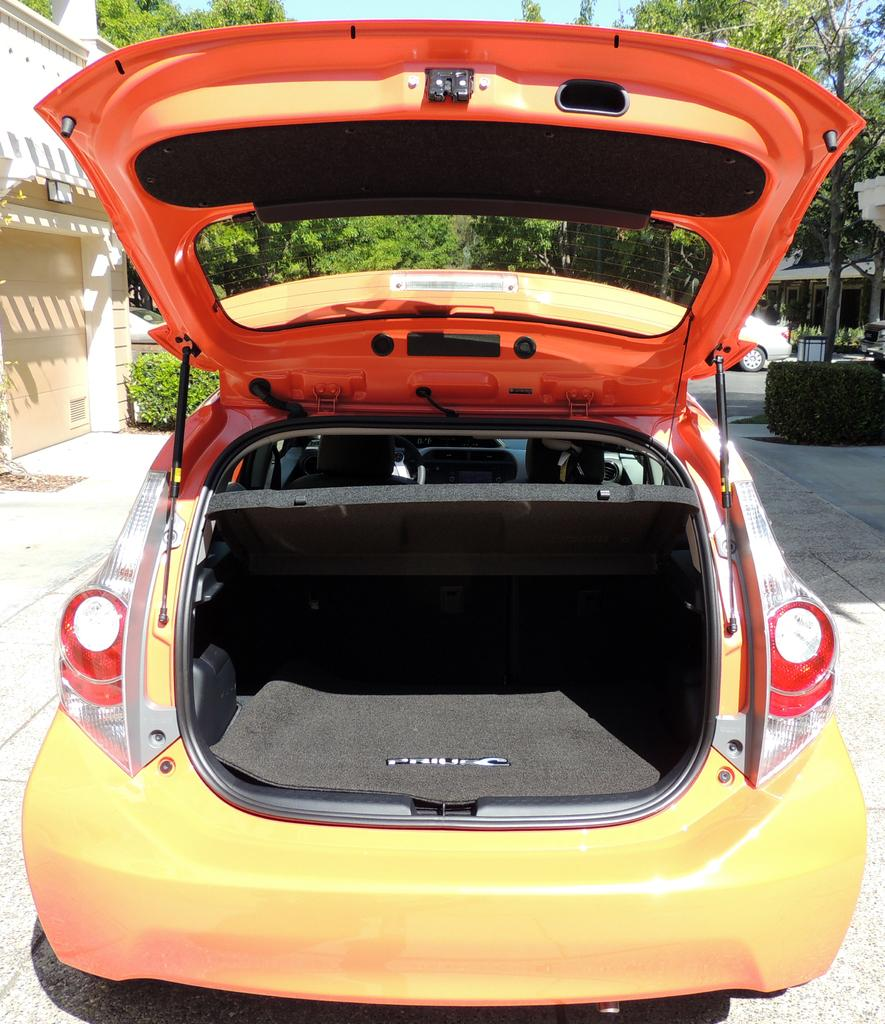What is parked on the road in the image? There is a car parked on the road in the image. What is the state of the car's back door? The back door of the car is opened. What can be seen in the background of the image? There is a building, a door, a group of trees, and plants visible in the background. Are there any other vehicles visible in the image? Yes, there is another car visible in the background. What date is circled on the calendar hanging on the door in the background? There is no calendar visible in the image, so it is not possible to answer that question. 